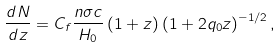Convert formula to latex. <formula><loc_0><loc_0><loc_500><loc_500>\frac { d N } { d z } = C _ { f } \frac { n \sigma c } { H _ { 0 } } \left ( 1 + z \right ) \left ( 1 + 2 q _ { 0 } z \right ) ^ { - 1 / 2 } ,</formula> 